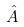<formula> <loc_0><loc_0><loc_500><loc_500>\hat { A }</formula> 